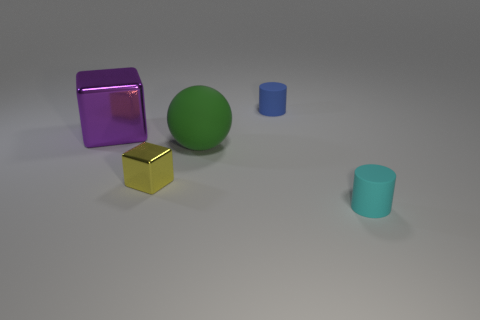What material is the tiny yellow object that is the same shape as the big purple thing?
Keep it short and to the point. Metal. There is a large green object to the left of the thing on the right side of the small blue thing; is there a large purple metallic block that is on the right side of it?
Keep it short and to the point. No. There is a tiny thing in front of the yellow block; is its shape the same as the metal object that is behind the small yellow block?
Ensure brevity in your answer.  No. Is the number of blue cylinders that are to the left of the tiny yellow object greater than the number of green objects?
Your answer should be compact. No. How many objects are either large brown balls or shiny cubes?
Provide a succinct answer. 2. The small metallic thing has what color?
Ensure brevity in your answer.  Yellow. How many other objects are there of the same color as the big shiny cube?
Offer a terse response. 0. There is a blue matte object; are there any yellow blocks right of it?
Provide a succinct answer. No. What is the color of the tiny rubber thing that is in front of the matte thing that is left of the tiny cylinder that is behind the big green thing?
Offer a very short reply. Cyan. How many tiny objects are in front of the green ball and to the right of the sphere?
Give a very brief answer. 1. 